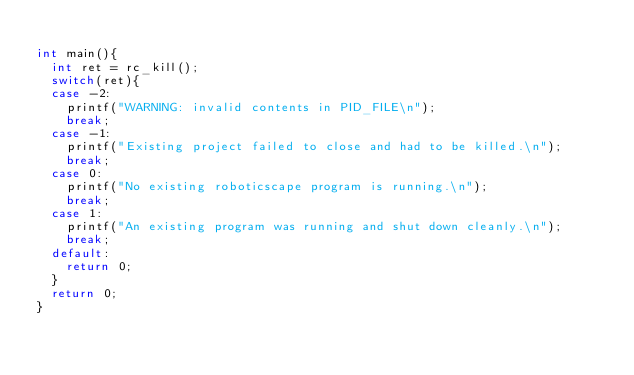Convert code to text. <code><loc_0><loc_0><loc_500><loc_500><_C_>
int main(){
	int ret = rc_kill();
	switch(ret){
	case -2:
		printf("WARNING: invalid contents in PID_FILE\n");
		break;
	case -1:
		printf("Existing project failed to close and had to be killed.\n");
		break;
	case 0:
		printf("No existing roboticscape program is running.\n");
		break;
	case 1:
		printf("An existing program was running and shut down cleanly.\n");
		break;
	default:
		return 0;
	}
	return 0;
}
</code> 